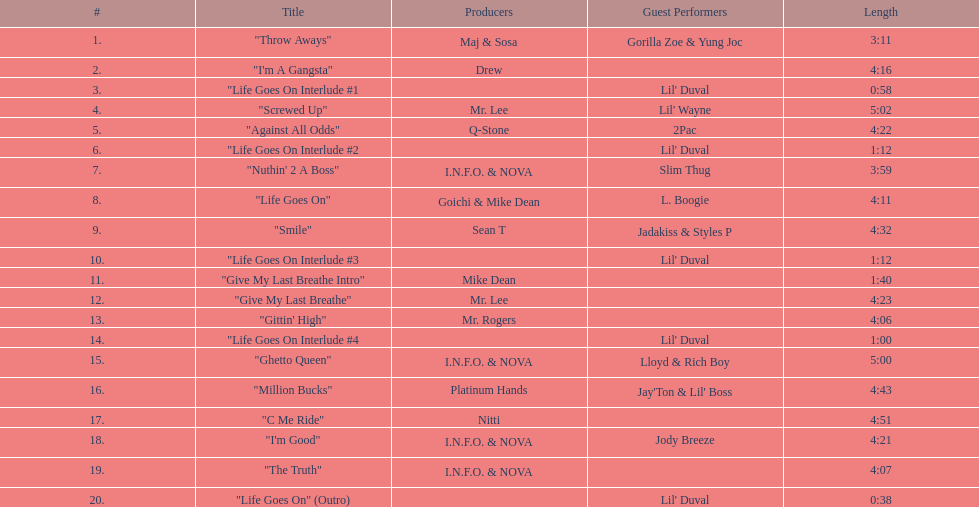What is the duration of track number 11? 1:40. 